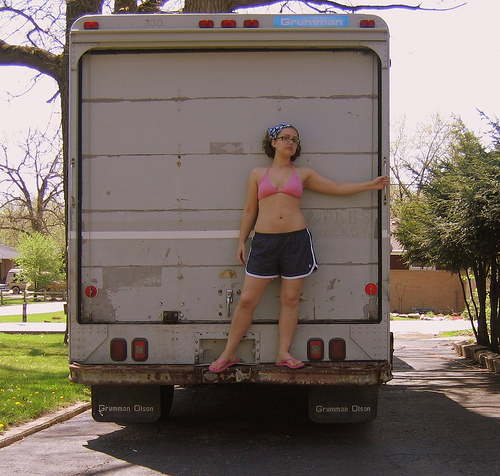<image>
Is the woman on the truck? Yes. Looking at the image, I can see the woman is positioned on top of the truck, with the truck providing support. Is the woman under the truck? No. The woman is not positioned under the truck. The vertical relationship between these objects is different. Is the woman behind the truck? Yes. From this viewpoint, the woman is positioned behind the truck, with the truck partially or fully occluding the woman. Is the fence behind the tree? Yes. From this viewpoint, the fence is positioned behind the tree, with the tree partially or fully occluding the fence. 